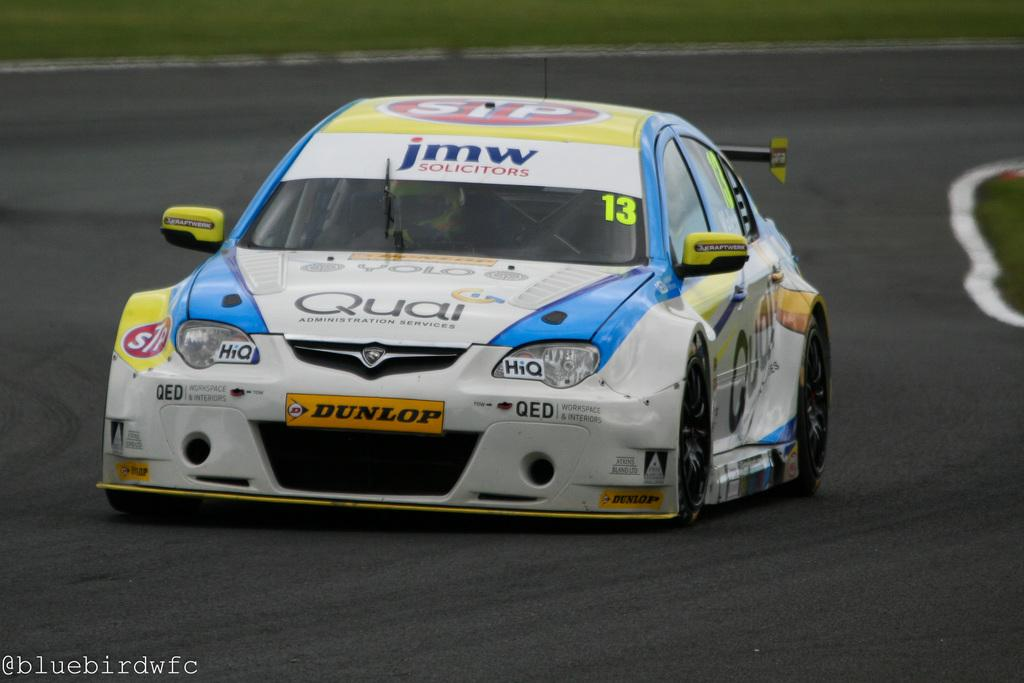What is the main subject of the image? The main subject of the image is a car. Where is the car located in the image? The car is on the road. What type of marble is used to decorate the car's interior in the image? There is no mention of marble or the car's interior in the image, so it cannot be determined from the image. 